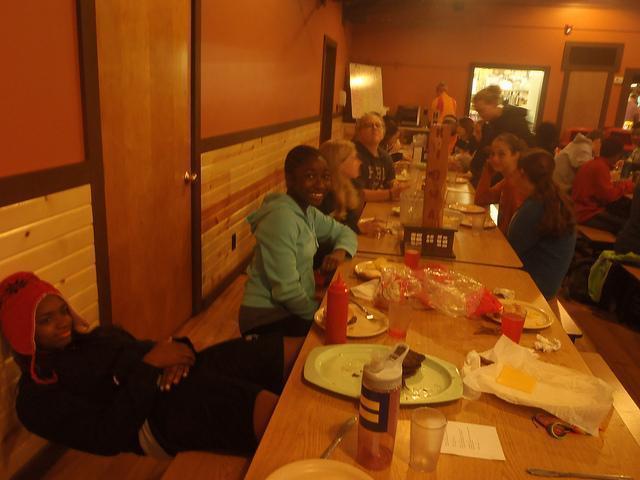How many people are there?
Give a very brief answer. 8. How many dining tables are there?
Give a very brief answer. 2. How many cups are there?
Give a very brief answer. 1. How many news anchors are on the television screen?
Give a very brief answer. 0. 